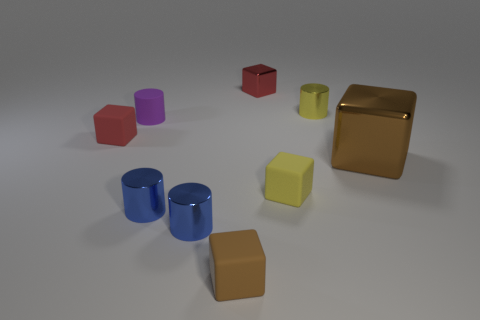Subtract 3 blocks. How many blocks are left? 2 Subtract all brown rubber cubes. How many cubes are left? 4 Subtract all yellow cubes. How many cubes are left? 4 Subtract all purple cubes. Subtract all cyan balls. How many cubes are left? 5 Add 1 blue cylinders. How many objects exist? 10 Subtract all cubes. How many objects are left? 4 Subtract all purple matte cylinders. Subtract all shiny blocks. How many objects are left? 6 Add 8 yellow rubber blocks. How many yellow rubber blocks are left? 9 Add 1 big red rubber cylinders. How many big red rubber cylinders exist? 1 Subtract 0 brown cylinders. How many objects are left? 9 